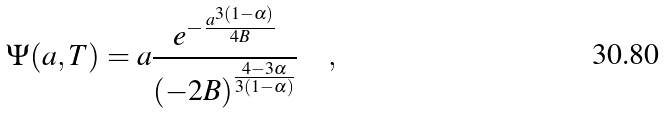Convert formula to latex. <formula><loc_0><loc_0><loc_500><loc_500>\Psi ( a , T ) = a \frac { e ^ { - \frac { a ^ { 3 ( 1 - \alpha ) } } { 4 B } } } { ( - 2 B ) ^ { \frac { 4 - 3 \alpha } { 3 ( 1 - \alpha ) } } } \quad ,</formula> 